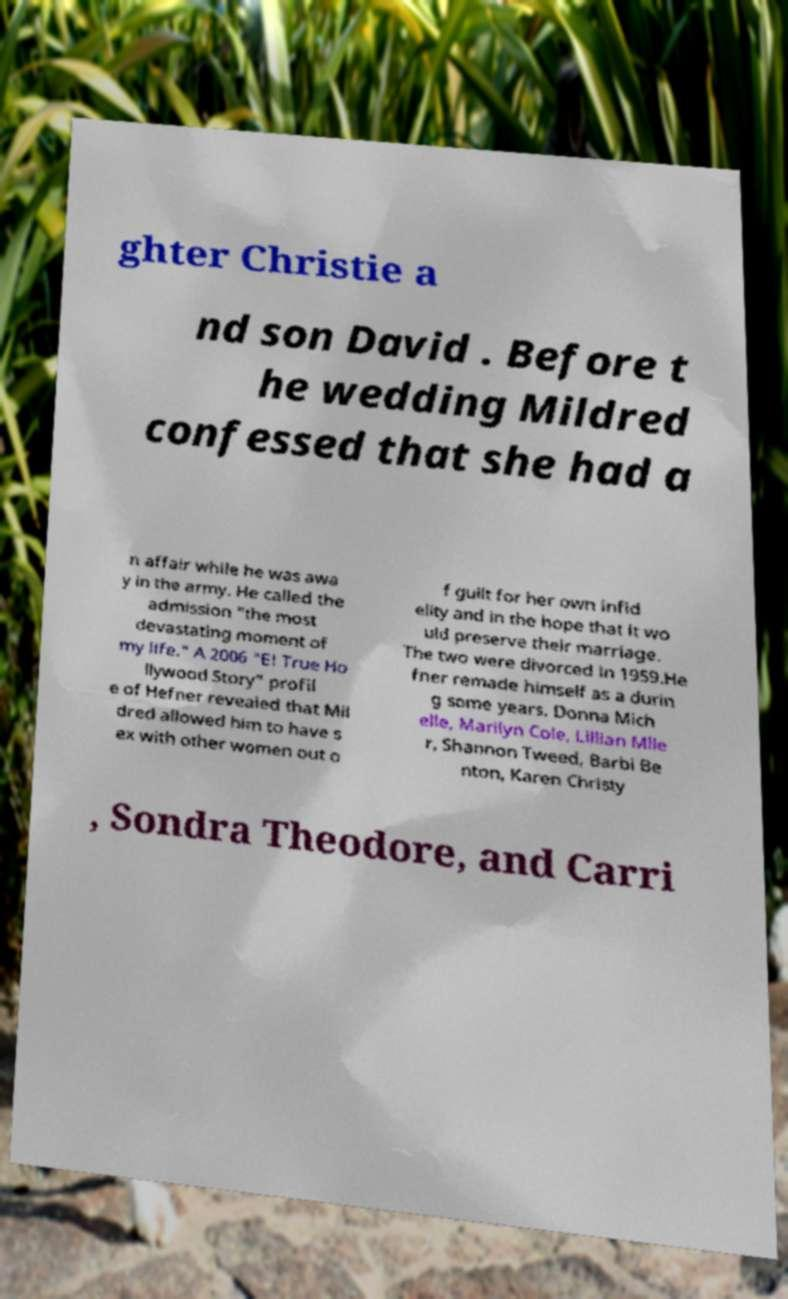Can you read and provide the text displayed in the image?This photo seems to have some interesting text. Can you extract and type it out for me? ghter Christie a nd son David . Before t he wedding Mildred confessed that she had a n affair while he was awa y in the army. He called the admission "the most devastating moment of my life." A 2006 "E! True Ho llywood Story" profil e of Hefner revealed that Mil dred allowed him to have s ex with other women out o f guilt for her own infid elity and in the hope that it wo uld preserve their marriage. The two were divorced in 1959.He fner remade himself as a durin g some years. Donna Mich elle, Marilyn Cole, Lillian Mlle r, Shannon Tweed, Barbi Be nton, Karen Christy , Sondra Theodore, and Carri 